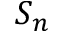Convert formula to latex. <formula><loc_0><loc_0><loc_500><loc_500>S _ { n }</formula> 